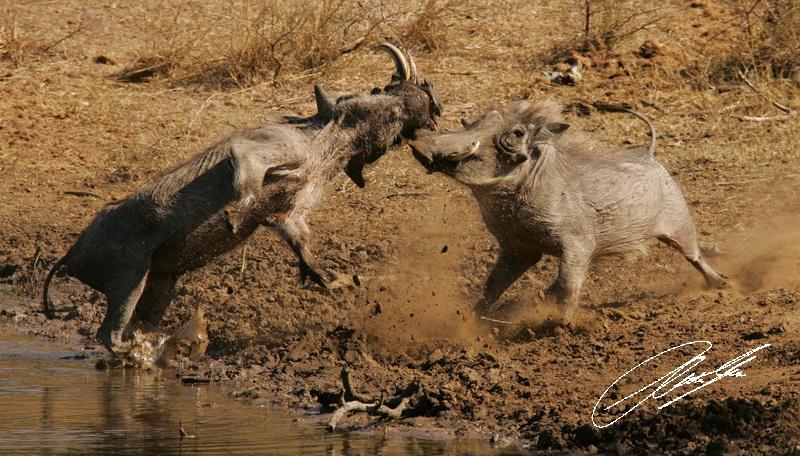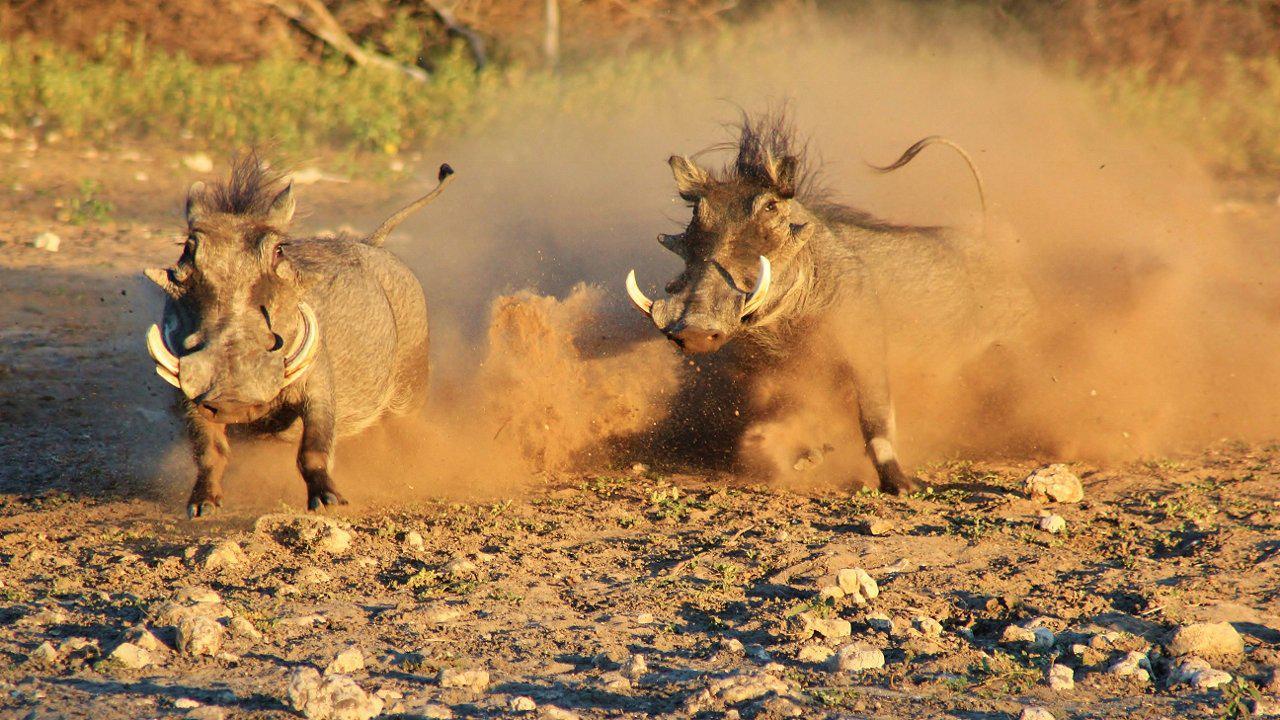The first image is the image on the left, the second image is the image on the right. Evaluate the accuracy of this statement regarding the images: "A warthog is fighting with a cheetah.". Is it true? Answer yes or no. No. The first image is the image on the left, the second image is the image on the right. Assess this claim about the two images: "a jaguar is attacking a warthog". Correct or not? Answer yes or no. No. 